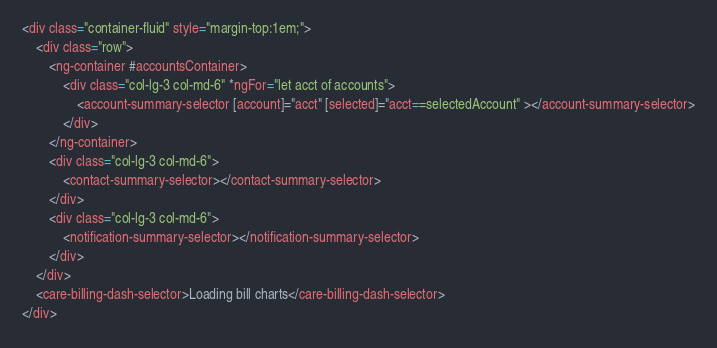Convert code to text. <code><loc_0><loc_0><loc_500><loc_500><_HTML_><div class="container-fluid" style="margin-top:1em;">
    <div class="row">
        <ng-container #accountsContainer>
            <div class="col-lg-3 col-md-6" *ngFor="let acct of accounts">
                <account-summary-selector [account]="acct" [selected]="acct==selectedAccount" ></account-summary-selector>
            </div>
        </ng-container>
        <div class="col-lg-3 col-md-6">
            <contact-summary-selector></contact-summary-selector>
        </div>
        <div class="col-lg-3 col-md-6">
            <notification-summary-selector></notification-summary-selector>
        </div>
    </div>
    <care-billing-dash-selector>Loading bill charts</care-billing-dash-selector>
</div></code> 